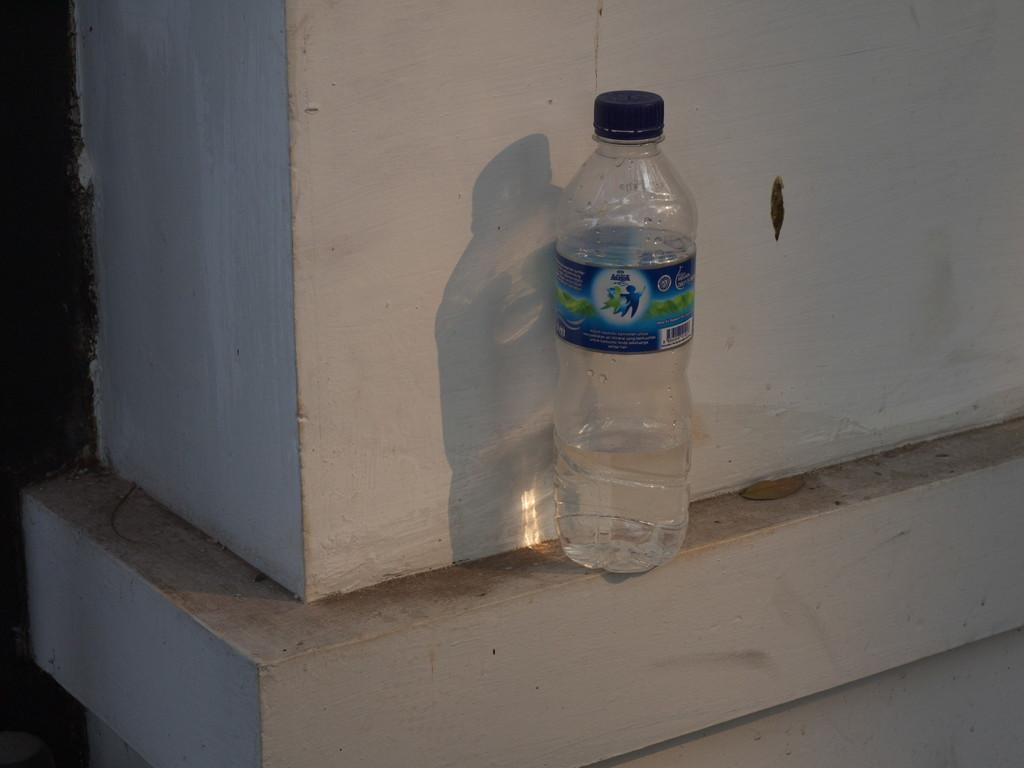What object is visible in the image? There is a water bottle in the image. Is the water bottle being used to teach a ghost how to use a screw in the image? There is no indication of a ghost or a screw in the image, and the water bottle is not being used for teaching purposes. 